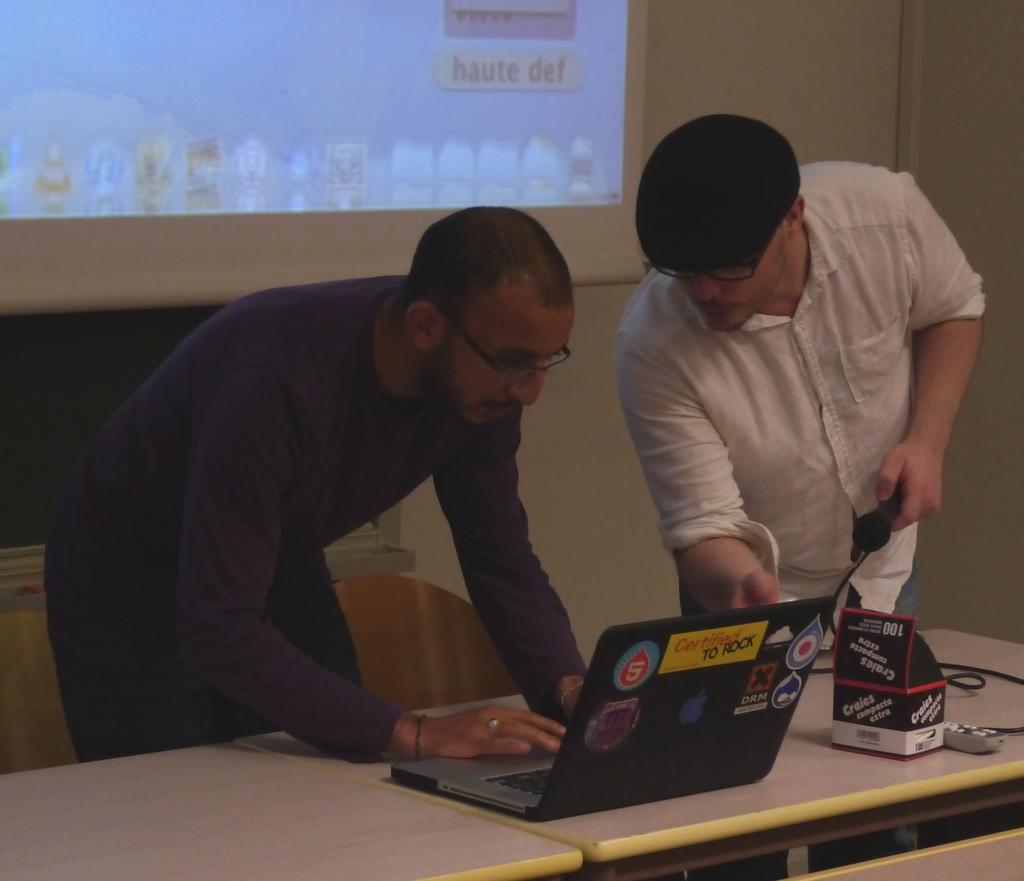How many people are in the image? There are two men in the image. What are the men doing in the image? The men are looking at a laptop. Where is the laptop located in the image? The laptop is on a table. What level of difficulty is the game set to on the laptop in the image? The provided facts do not mention any game or level of difficulty, so it is not possible to determine the game's difficulty level from the image. 